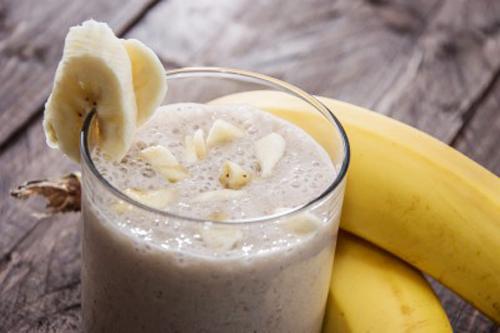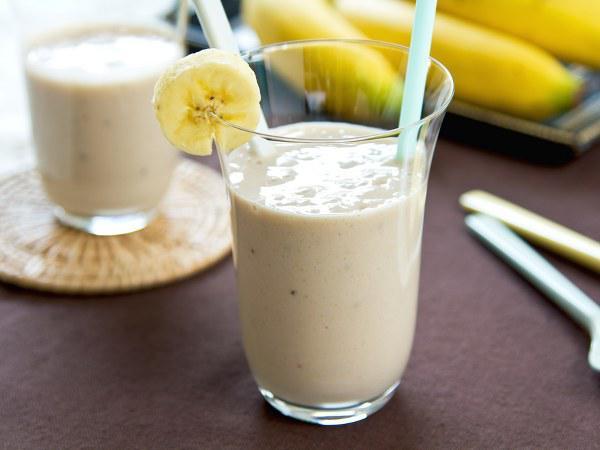The first image is the image on the left, the second image is the image on the right. For the images shown, is this caption "One glass of creamy beverage has a straw standing in it, and at least one glass of creamy beverage has a wedge of fruit on the rim of the glass." true? Answer yes or no. Yes. The first image is the image on the left, the second image is the image on the right. Examine the images to the left and right. Is the description "One of the drinks has a straw in it." accurate? Answer yes or no. Yes. 